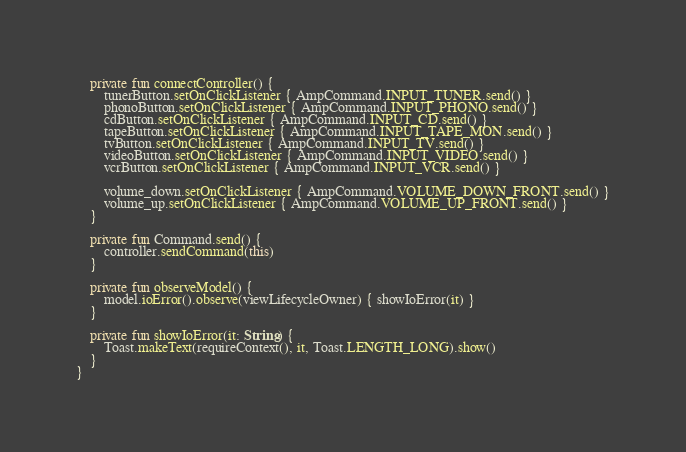Convert code to text. <code><loc_0><loc_0><loc_500><loc_500><_Kotlin_>
    private fun connectController() {
        tunerButton.setOnClickListener { AmpCommand.INPUT_TUNER.send() }
        phonoButton.setOnClickListener { AmpCommand.INPUT_PHONO.send() }
        cdButton.setOnClickListener { AmpCommand.INPUT_CD.send() }
        tapeButton.setOnClickListener { AmpCommand.INPUT_TAPE_MON.send() }
        tvButton.setOnClickListener { AmpCommand.INPUT_TV.send() }
        videoButton.setOnClickListener { AmpCommand.INPUT_VIDEO.send() }
        vcrButton.setOnClickListener { AmpCommand.INPUT_VCR.send() }

        volume_down.setOnClickListener { AmpCommand.VOLUME_DOWN_FRONT.send() }
        volume_up.setOnClickListener { AmpCommand.VOLUME_UP_FRONT.send() }
    }

    private fun Command.send() {
        controller.sendCommand(this)
    }

    private fun observeModel() {
        model.ioError().observe(viewLifecycleOwner) { showIoError(it) }
    }

    private fun showIoError(it: String) {
        Toast.makeText(requireContext(), it, Toast.LENGTH_LONG).show()
    }
}
</code> 